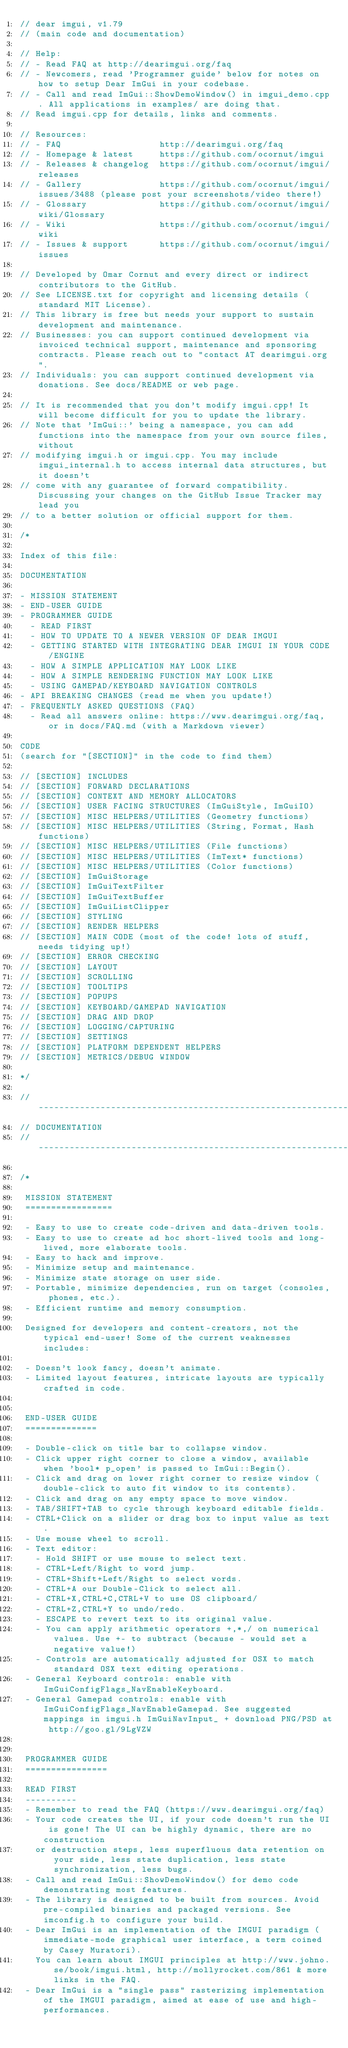<code> <loc_0><loc_0><loc_500><loc_500><_C++_>// dear imgui, v1.79
// (main code and documentation)

// Help:
// - Read FAQ at http://dearimgui.org/faq
// - Newcomers, read 'Programmer guide' below for notes on how to setup Dear ImGui in your codebase.
// - Call and read ImGui::ShowDemoWindow() in imgui_demo.cpp. All applications in examples/ are doing that.
// Read imgui.cpp for details, links and comments.

// Resources:
// - FAQ                   http://dearimgui.org/faq
// - Homepage & latest     https://github.com/ocornut/imgui
// - Releases & changelog  https://github.com/ocornut/imgui/releases
// - Gallery               https://github.com/ocornut/imgui/issues/3488 (please post your screenshots/video there!)
// - Glossary              https://github.com/ocornut/imgui/wiki/Glossary
// - Wiki                  https://github.com/ocornut/imgui/wiki
// - Issues & support      https://github.com/ocornut/imgui/issues

// Developed by Omar Cornut and every direct or indirect contributors to the GitHub.
// See LICENSE.txt for copyright and licensing details (standard MIT License).
// This library is free but needs your support to sustain development and maintenance.
// Businesses: you can support continued development via invoiced technical support, maintenance and sponsoring contracts. Please reach out to "contact AT dearimgui.org".
// Individuals: you can support continued development via donations. See docs/README or web page.

// It is recommended that you don't modify imgui.cpp! It will become difficult for you to update the library.
// Note that 'ImGui::' being a namespace, you can add functions into the namespace from your own source files, without
// modifying imgui.h or imgui.cpp. You may include imgui_internal.h to access internal data structures, but it doesn't
// come with any guarantee of forward compatibility. Discussing your changes on the GitHub Issue Tracker may lead you
// to a better solution or official support for them.

/*

Index of this file:

DOCUMENTATION

- MISSION STATEMENT
- END-USER GUIDE
- PROGRAMMER GUIDE
  - READ FIRST
  - HOW TO UPDATE TO A NEWER VERSION OF DEAR IMGUI
  - GETTING STARTED WITH INTEGRATING DEAR IMGUI IN YOUR CODE/ENGINE
  - HOW A SIMPLE APPLICATION MAY LOOK LIKE
  - HOW A SIMPLE RENDERING FUNCTION MAY LOOK LIKE
  - USING GAMEPAD/KEYBOARD NAVIGATION CONTROLS
- API BREAKING CHANGES (read me when you update!)
- FREQUENTLY ASKED QUESTIONS (FAQ)
  - Read all answers online: https://www.dearimgui.org/faq, or in docs/FAQ.md (with a Markdown viewer)

CODE
(search for "[SECTION]" in the code to find them)

// [SECTION] INCLUDES
// [SECTION] FORWARD DECLARATIONS
// [SECTION] CONTEXT AND MEMORY ALLOCATORS
// [SECTION] USER FACING STRUCTURES (ImGuiStyle, ImGuiIO)
// [SECTION] MISC HELPERS/UTILITIES (Geometry functions)
// [SECTION] MISC HELPERS/UTILITIES (String, Format, Hash functions)
// [SECTION] MISC HELPERS/UTILITIES (File functions)
// [SECTION] MISC HELPERS/UTILITIES (ImText* functions)
// [SECTION] MISC HELPERS/UTILITIES (Color functions)
// [SECTION] ImGuiStorage
// [SECTION] ImGuiTextFilter
// [SECTION] ImGuiTextBuffer
// [SECTION] ImGuiListClipper
// [SECTION] STYLING
// [SECTION] RENDER HELPERS
// [SECTION] MAIN CODE (most of the code! lots of stuff, needs tidying up!)
// [SECTION] ERROR CHECKING
// [SECTION] LAYOUT
// [SECTION] SCROLLING
// [SECTION] TOOLTIPS
// [SECTION] POPUPS
// [SECTION] KEYBOARD/GAMEPAD NAVIGATION
// [SECTION] DRAG AND DROP
// [SECTION] LOGGING/CAPTURING
// [SECTION] SETTINGS
// [SECTION] PLATFORM DEPENDENT HELPERS
// [SECTION] METRICS/DEBUG WINDOW

*/

//-----------------------------------------------------------------------------
// DOCUMENTATION
//-----------------------------------------------------------------------------

/*

 MISSION STATEMENT
 =================

 - Easy to use to create code-driven and data-driven tools.
 - Easy to use to create ad hoc short-lived tools and long-lived, more elaborate tools.
 - Easy to hack and improve.
 - Minimize setup and maintenance.
 - Minimize state storage on user side.
 - Portable, minimize dependencies, run on target (consoles, phones, etc.).
 - Efficient runtime and memory consumption.

 Designed for developers and content-creators, not the typical end-user! Some of the current weaknesses includes:

 - Doesn't look fancy, doesn't animate.
 - Limited layout features, intricate layouts are typically crafted in code.


 END-USER GUIDE
 ==============

 - Double-click on title bar to collapse window.
 - Click upper right corner to close a window, available when 'bool* p_open' is passed to ImGui::Begin().
 - Click and drag on lower right corner to resize window (double-click to auto fit window to its contents).
 - Click and drag on any empty space to move window.
 - TAB/SHIFT+TAB to cycle through keyboard editable fields.
 - CTRL+Click on a slider or drag box to input value as text.
 - Use mouse wheel to scroll.
 - Text editor:
   - Hold SHIFT or use mouse to select text.
   - CTRL+Left/Right to word jump.
   - CTRL+Shift+Left/Right to select words.
   - CTRL+A our Double-Click to select all.
   - CTRL+X,CTRL+C,CTRL+V to use OS clipboard/
   - CTRL+Z,CTRL+Y to undo/redo.
   - ESCAPE to revert text to its original value.
   - You can apply arithmetic operators +,*,/ on numerical values. Use +- to subtract (because - would set a negative value!)
   - Controls are automatically adjusted for OSX to match standard OSX text editing operations.
 - General Keyboard controls: enable with ImGuiConfigFlags_NavEnableKeyboard.
 - General Gamepad controls: enable with ImGuiConfigFlags_NavEnableGamepad. See suggested mappings in imgui.h ImGuiNavInput_ + download PNG/PSD at http://goo.gl/9LgVZW


 PROGRAMMER GUIDE
 ================

 READ FIRST
 ----------
 - Remember to read the FAQ (https://www.dearimgui.org/faq)
 - Your code creates the UI, if your code doesn't run the UI is gone! The UI can be highly dynamic, there are no construction
   or destruction steps, less superfluous data retention on your side, less state duplication, less state synchronization, less bugs.
 - Call and read ImGui::ShowDemoWindow() for demo code demonstrating most features.
 - The library is designed to be built from sources. Avoid pre-compiled binaries and packaged versions. See imconfig.h to configure your build.
 - Dear ImGui is an implementation of the IMGUI paradigm (immediate-mode graphical user interface, a term coined by Casey Muratori).
   You can learn about IMGUI principles at http://www.johno.se/book/imgui.html, http://mollyrocket.com/861 & more links in the FAQ.
 - Dear ImGui is a "single pass" rasterizing implementation of the IMGUI paradigm, aimed at ease of use and high-performances.</code> 